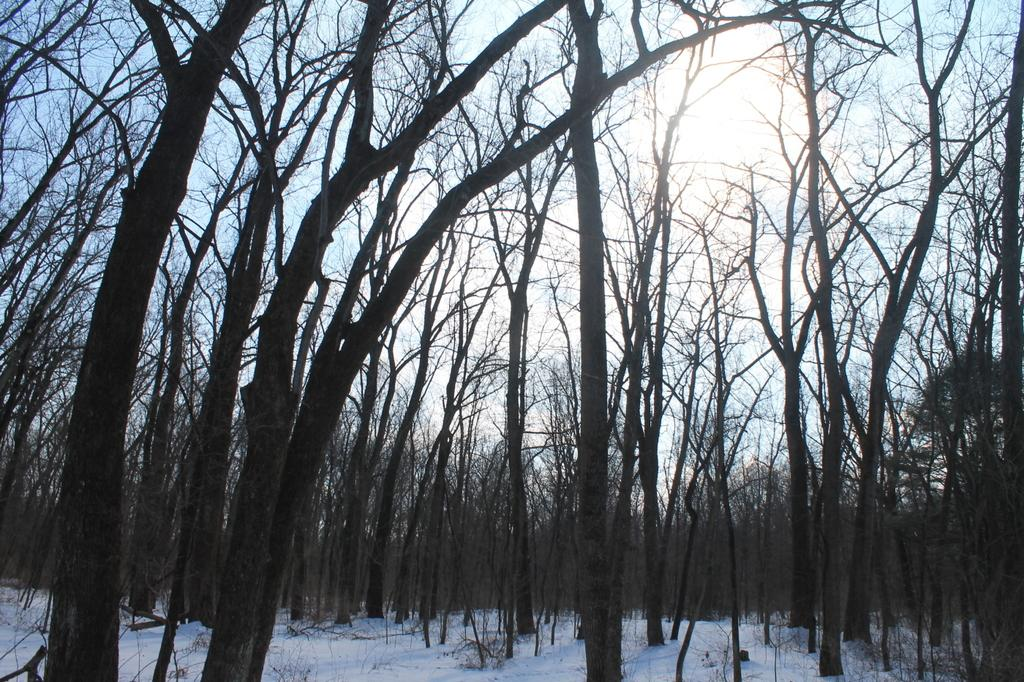What type of vegetation can be seen in the image? There are trees in the image. What is covering the ground in the image? The ground is covered with snow. What part of the natural environment is visible in the image? The sky is visible in the image. What is the source of light in the image? Sunlight is present in the image. What type of fang can be seen in the image? There is no fang present in the image. How does the sponge absorb the snow in the image? There is no sponge present in the image; the ground is covered with snow. 